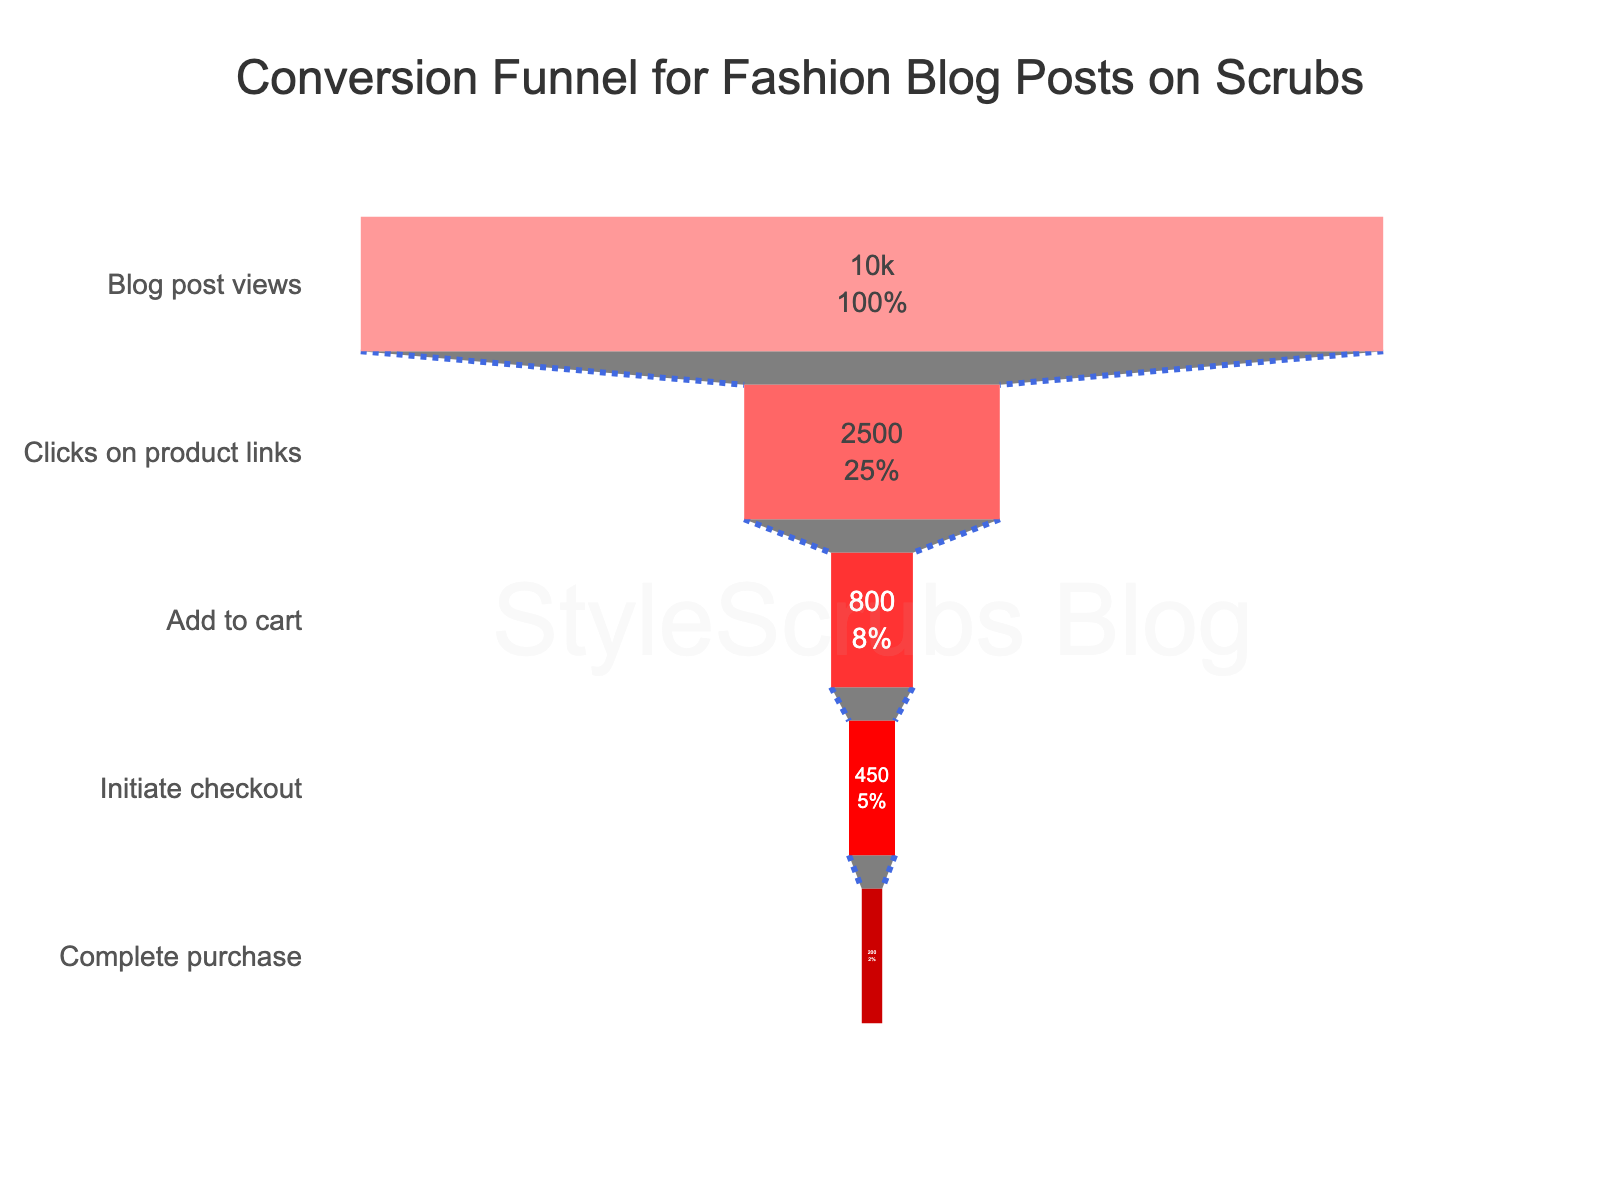What's the title of the funnel chart? The title is usually the text at the top of the chart. In this chart, the title is displayed centrally and prominently formatted.
Answer: Conversion Funnel for Fashion Blog Posts on Scrubs How many stages are there in the funnel chart? Count the number of distinct entries in the stage labels presented on the Y-axis of the chart.
Answer: 5 Which stage has the highest number of users? Identify the stage with the highest value in the "Number of Users" displayed on the X-axis.
Answer: Blog post views What is the completion rate from blog post views to purchases? Divide the number of users who completed the purchase by the number who viewed the blog post, then multiply by 100 to get the percentage. (200/10000) * 100 = 2%
Answer: 2% How many users added the products to the cart but didn't initiate checkout? Subtract the number of users who initiated checkout from the number of users who added the product to the cart. 800 - 450 = 350
Answer: 350 What percentage of users clicked on product links after viewing the blog post? Divide the number of users who clicked on product links by the number who viewed the blog post, then multiply by 100 to get the percentage. (2500/10000) * 100 = 25%
Answer: 25% What is the difference between users who added products to the cart and users who completed the purchase? Subtract the number of users who completed the purchase from the number of users who added products to the cart. 800 - 200 = 600
Answer: 600 Which two stages have the largest drop-off in the number of users? Compare the differences in the number of users between successive stages to determine which two have the largest drop-off. The largest drop-off is between "Clicks on product links" and "Add to cart" (2500 - 800 = 1700).
Answer: Clicks on product links and Add to cart How many users did not proceed to purchase after initiating checkout? Subtract the number of users who completed the purchase from the number who initiated checkout. 450 - 200 = 250
Answer: 250 What fraction of users added products to the cart out of those who viewed the blog post? Divide the number of users who added products to the cart by the number of users who viewed the blog post. 800/10000 = 0.08
Answer: 0.08 